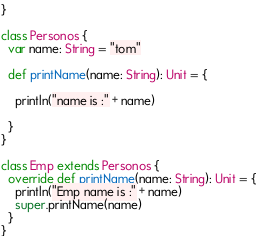Convert code to text. <code><loc_0><loc_0><loc_500><loc_500><_Scala_>}

class Personos {
  var name: String = "tom"

  def printName(name: String): Unit = {

    println("name is :" + name)

  }
}

class Emp extends Personos {
  override def printName(name: String): Unit = {
    println("Emp name is :" + name)
    super.printName(name)
  }
}</code> 